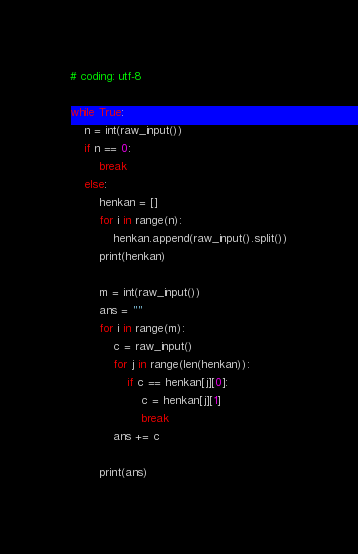<code> <loc_0><loc_0><loc_500><loc_500><_Python_># coding: utf-8

while True:
	n = int(raw_input())
	if n == 0:
		break
	else:
		henkan = []
		for i in range(n):
			henkan.append(raw_input().split())
		print(henkan)

		m = int(raw_input())
		ans = ""
		for i in range(m):
			c = raw_input()
			for j in range(len(henkan)):
				if c == henkan[j][0]:
					c = henkan[j][1]
					break
			ans += c

		print(ans)</code> 